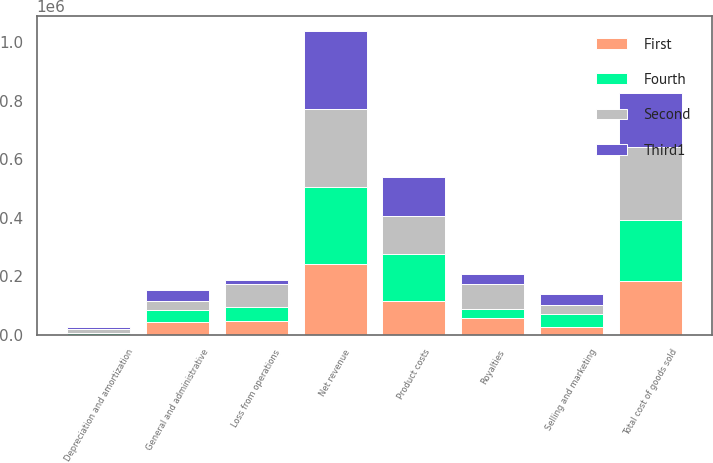Convert chart to OTSL. <chart><loc_0><loc_0><loc_500><loc_500><stacked_bar_chart><ecel><fcel>Net revenue<fcel>Product costs<fcel>Royalties<fcel>Total cost of goods sold<fcel>Selling and marketing<fcel>General and administrative<fcel>Depreciation and amortization<fcel>Loss from operations<nl><fcel>Fourth<fcel>264981<fcel>160853<fcel>32867<fcel>209314<fcel>41644<fcel>38453<fcel>6651<fcel>48790<nl><fcel>Second<fcel>265122<fcel>130940<fcel>82282<fcel>247350<fcel>32194<fcel>33705<fcel>12944<fcel>77168<nl><fcel>First<fcel>241181<fcel>115245<fcel>56443<fcel>184055<fcel>27585<fcel>44118<fcel>183<fcel>46944<nl><fcel>Third1<fcel>266556<fcel>131723<fcel>35244<fcel>184757<fcel>37827<fcel>37739<fcel>6621<fcel>14264<nl></chart> 